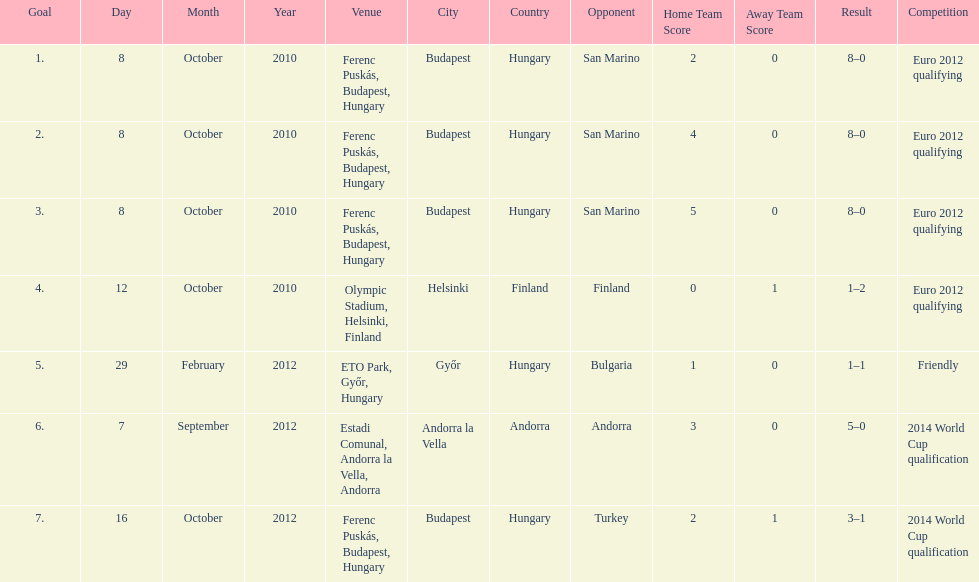Szalai scored only one more international goal against all other countries put together than he did against what one country? San Marino. 